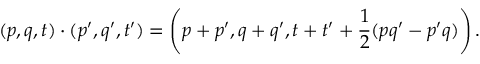Convert formula to latex. <formula><loc_0><loc_0><loc_500><loc_500>( p , q , t ) \cdot ( p ^ { \prime } , q ^ { \prime } , t ^ { \prime } ) = \left ( p + p ^ { \prime } , q + q ^ { \prime } , t + t ^ { \prime } + { \frac { 1 } { 2 } } ( p q ^ { \prime } - p ^ { \prime } q ) \right ) .</formula> 